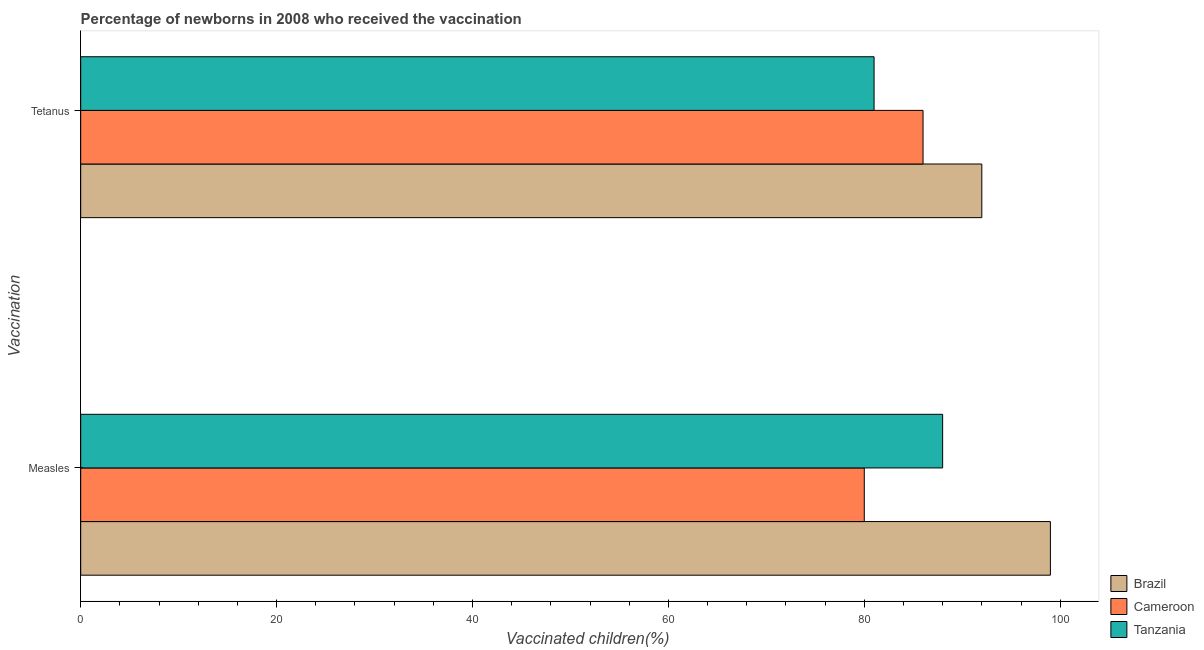Are the number of bars per tick equal to the number of legend labels?
Offer a very short reply. Yes. Are the number of bars on each tick of the Y-axis equal?
Your answer should be compact. Yes. How many bars are there on the 1st tick from the top?
Your answer should be compact. 3. How many bars are there on the 1st tick from the bottom?
Your answer should be very brief. 3. What is the label of the 1st group of bars from the top?
Ensure brevity in your answer.  Tetanus. What is the percentage of newborns who received vaccination for tetanus in Cameroon?
Provide a short and direct response. 86. Across all countries, what is the maximum percentage of newborns who received vaccination for tetanus?
Keep it short and to the point. 92. Across all countries, what is the minimum percentage of newborns who received vaccination for measles?
Make the answer very short. 80. In which country was the percentage of newborns who received vaccination for tetanus maximum?
Offer a very short reply. Brazil. In which country was the percentage of newborns who received vaccination for measles minimum?
Provide a short and direct response. Cameroon. What is the total percentage of newborns who received vaccination for tetanus in the graph?
Your answer should be very brief. 259. What is the difference between the percentage of newborns who received vaccination for measles in Tanzania and the percentage of newborns who received vaccination for tetanus in Brazil?
Offer a very short reply. -4. What is the average percentage of newborns who received vaccination for measles per country?
Your response must be concise. 89. What is the difference between the percentage of newborns who received vaccination for tetanus and percentage of newborns who received vaccination for measles in Cameroon?
Provide a succinct answer. 6. What is the ratio of the percentage of newborns who received vaccination for measles in Tanzania to that in Brazil?
Your answer should be very brief. 0.89. In how many countries, is the percentage of newborns who received vaccination for tetanus greater than the average percentage of newborns who received vaccination for tetanus taken over all countries?
Ensure brevity in your answer.  1. What does the 2nd bar from the bottom in Measles represents?
Your response must be concise. Cameroon. What is the difference between two consecutive major ticks on the X-axis?
Provide a succinct answer. 20. Does the graph contain any zero values?
Provide a succinct answer. No. Does the graph contain grids?
Your answer should be compact. No. Where does the legend appear in the graph?
Make the answer very short. Bottom right. How many legend labels are there?
Make the answer very short. 3. What is the title of the graph?
Your response must be concise. Percentage of newborns in 2008 who received the vaccination. Does "High income" appear as one of the legend labels in the graph?
Your response must be concise. No. What is the label or title of the X-axis?
Make the answer very short. Vaccinated children(%)
. What is the label or title of the Y-axis?
Offer a terse response. Vaccination. What is the Vaccinated children(%)
 of Brazil in Measles?
Provide a short and direct response. 99. What is the Vaccinated children(%)
 of Cameroon in Measles?
Offer a terse response. 80. What is the Vaccinated children(%)
 in Brazil in Tetanus?
Your response must be concise. 92. Across all Vaccination, what is the maximum Vaccinated children(%)
 in Brazil?
Offer a terse response. 99. Across all Vaccination, what is the minimum Vaccinated children(%)
 in Brazil?
Your answer should be very brief. 92. Across all Vaccination, what is the minimum Vaccinated children(%)
 of Cameroon?
Provide a short and direct response. 80. Across all Vaccination, what is the minimum Vaccinated children(%)
 of Tanzania?
Provide a short and direct response. 81. What is the total Vaccinated children(%)
 of Brazil in the graph?
Keep it short and to the point. 191. What is the total Vaccinated children(%)
 in Cameroon in the graph?
Your response must be concise. 166. What is the total Vaccinated children(%)
 of Tanzania in the graph?
Your response must be concise. 169. What is the difference between the Vaccinated children(%)
 in Brazil in Measles and that in Tetanus?
Your answer should be very brief. 7. What is the difference between the Vaccinated children(%)
 in Brazil in Measles and the Vaccinated children(%)
 in Tanzania in Tetanus?
Your response must be concise. 18. What is the difference between the Vaccinated children(%)
 of Cameroon in Measles and the Vaccinated children(%)
 of Tanzania in Tetanus?
Offer a terse response. -1. What is the average Vaccinated children(%)
 in Brazil per Vaccination?
Your answer should be very brief. 95.5. What is the average Vaccinated children(%)
 in Cameroon per Vaccination?
Provide a succinct answer. 83. What is the average Vaccinated children(%)
 of Tanzania per Vaccination?
Keep it short and to the point. 84.5. What is the difference between the Vaccinated children(%)
 in Brazil and Vaccinated children(%)
 in Tanzania in Measles?
Your answer should be compact. 11. What is the difference between the Vaccinated children(%)
 in Cameroon and Vaccinated children(%)
 in Tanzania in Measles?
Offer a terse response. -8. What is the difference between the Vaccinated children(%)
 in Brazil and Vaccinated children(%)
 in Cameroon in Tetanus?
Make the answer very short. 6. What is the difference between the Vaccinated children(%)
 in Brazil and Vaccinated children(%)
 in Tanzania in Tetanus?
Keep it short and to the point. 11. What is the difference between the Vaccinated children(%)
 of Cameroon and Vaccinated children(%)
 of Tanzania in Tetanus?
Provide a succinct answer. 5. What is the ratio of the Vaccinated children(%)
 in Brazil in Measles to that in Tetanus?
Offer a terse response. 1.08. What is the ratio of the Vaccinated children(%)
 in Cameroon in Measles to that in Tetanus?
Ensure brevity in your answer.  0.93. What is the ratio of the Vaccinated children(%)
 of Tanzania in Measles to that in Tetanus?
Offer a very short reply. 1.09. What is the difference between the highest and the second highest Vaccinated children(%)
 of Brazil?
Provide a succinct answer. 7. What is the difference between the highest and the second highest Vaccinated children(%)
 in Cameroon?
Offer a terse response. 6. What is the difference between the highest and the second highest Vaccinated children(%)
 of Tanzania?
Keep it short and to the point. 7. What is the difference between the highest and the lowest Vaccinated children(%)
 in Tanzania?
Your response must be concise. 7. 